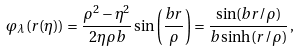Convert formula to latex. <formula><loc_0><loc_0><loc_500><loc_500>\varphi _ { \lambda } ( r ( \eta ) ) = \frac { \rho ^ { 2 } - \eta ^ { 2 } } { 2 \eta \rho b } \sin \left ( \frac { b r } { \rho } \right ) = \frac { \sin ( b r / \rho ) } { b \sinh ( r / \rho ) } \, ,</formula> 